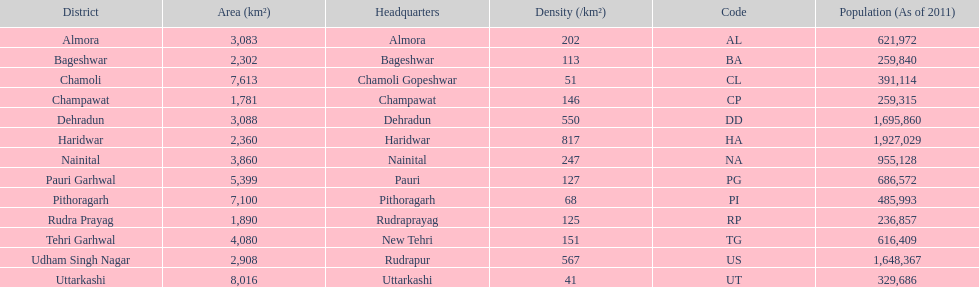Which code is above cl BA. 